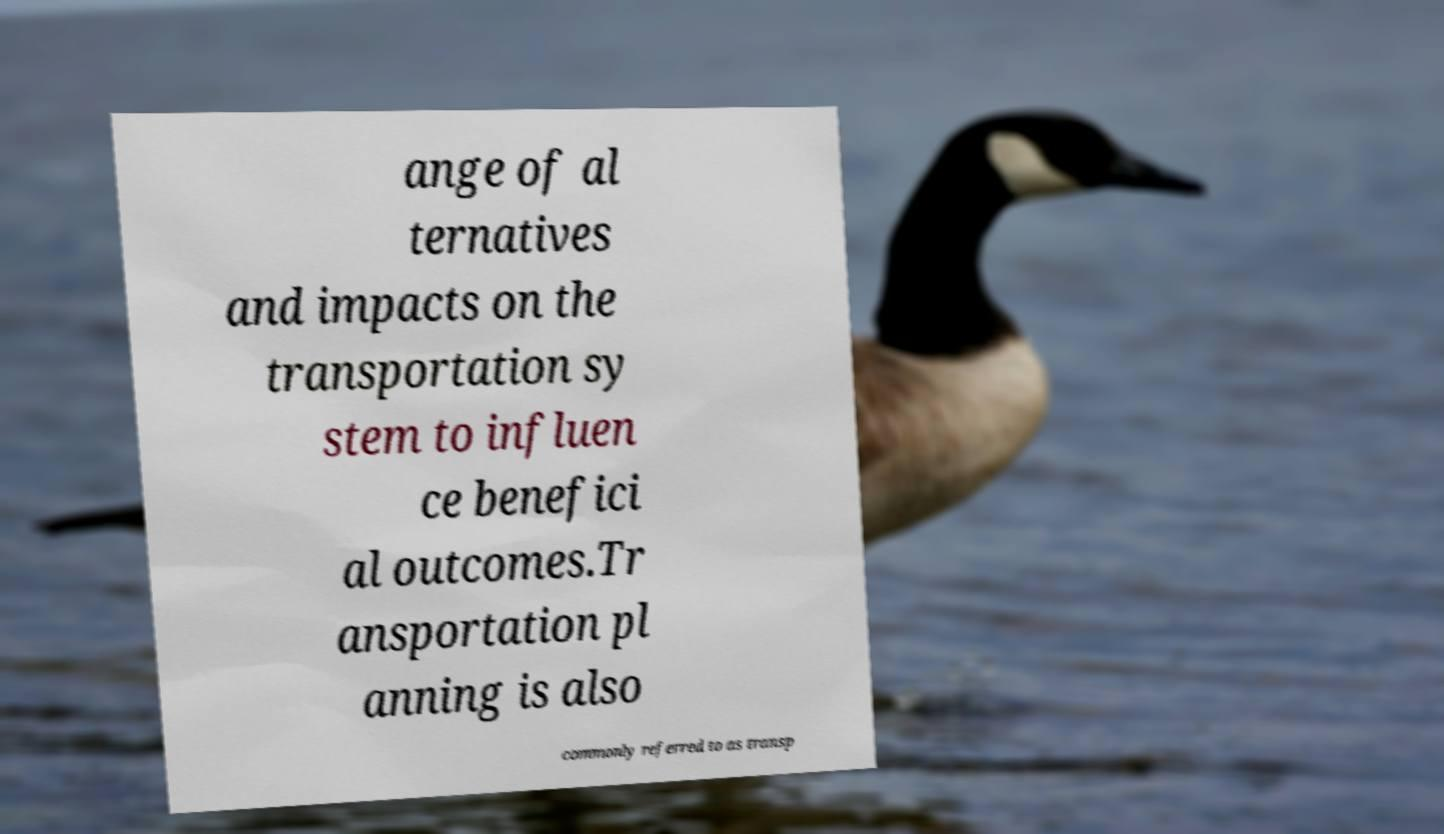What messages or text are displayed in this image? I need them in a readable, typed format. ange of al ternatives and impacts on the transportation sy stem to influen ce benefici al outcomes.Tr ansportation pl anning is also commonly referred to as transp 